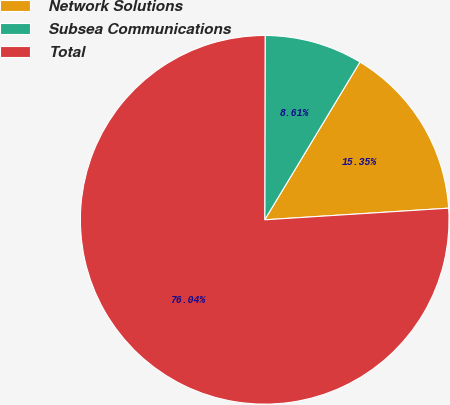Convert chart to OTSL. <chart><loc_0><loc_0><loc_500><loc_500><pie_chart><fcel>Network Solutions<fcel>Subsea Communications<fcel>Total<nl><fcel>15.35%<fcel>8.61%<fcel>76.04%<nl></chart> 